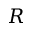<formula> <loc_0><loc_0><loc_500><loc_500>R</formula> 